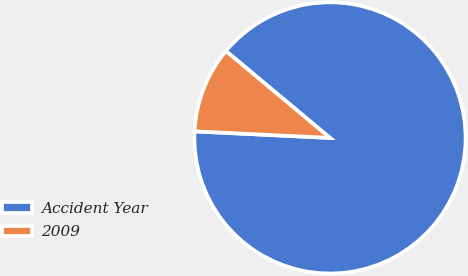<chart> <loc_0><loc_0><loc_500><loc_500><pie_chart><fcel>Accident Year<fcel>2009<nl><fcel>89.7%<fcel>10.3%<nl></chart> 